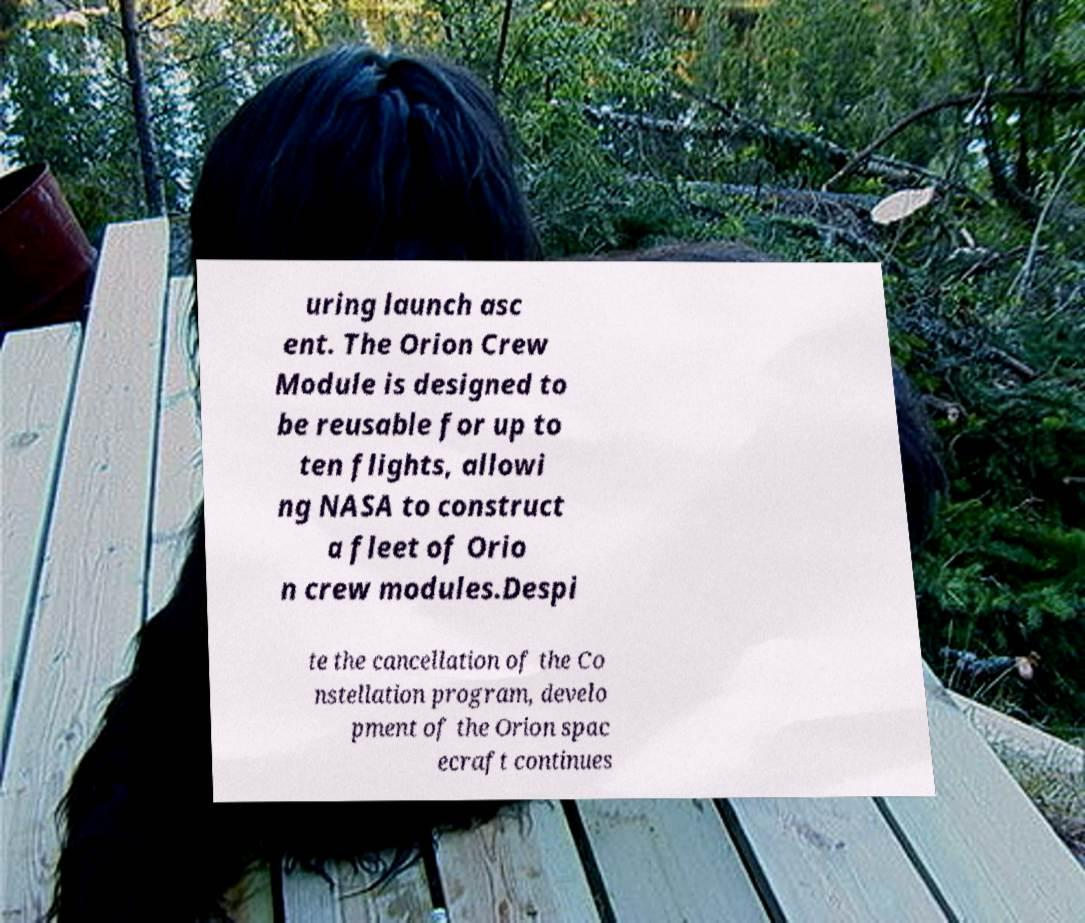Please identify and transcribe the text found in this image. uring launch asc ent. The Orion Crew Module is designed to be reusable for up to ten flights, allowi ng NASA to construct a fleet of Orio n crew modules.Despi te the cancellation of the Co nstellation program, develo pment of the Orion spac ecraft continues 